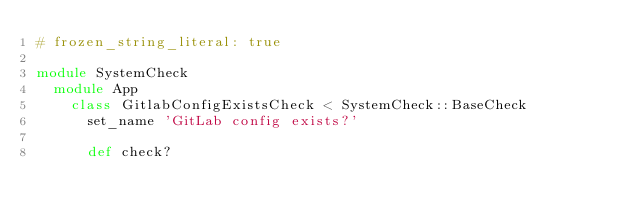Convert code to text. <code><loc_0><loc_0><loc_500><loc_500><_Ruby_># frozen_string_literal: true

module SystemCheck
  module App
    class GitlabConfigExistsCheck < SystemCheck::BaseCheck
      set_name 'GitLab config exists?'

      def check?</code> 